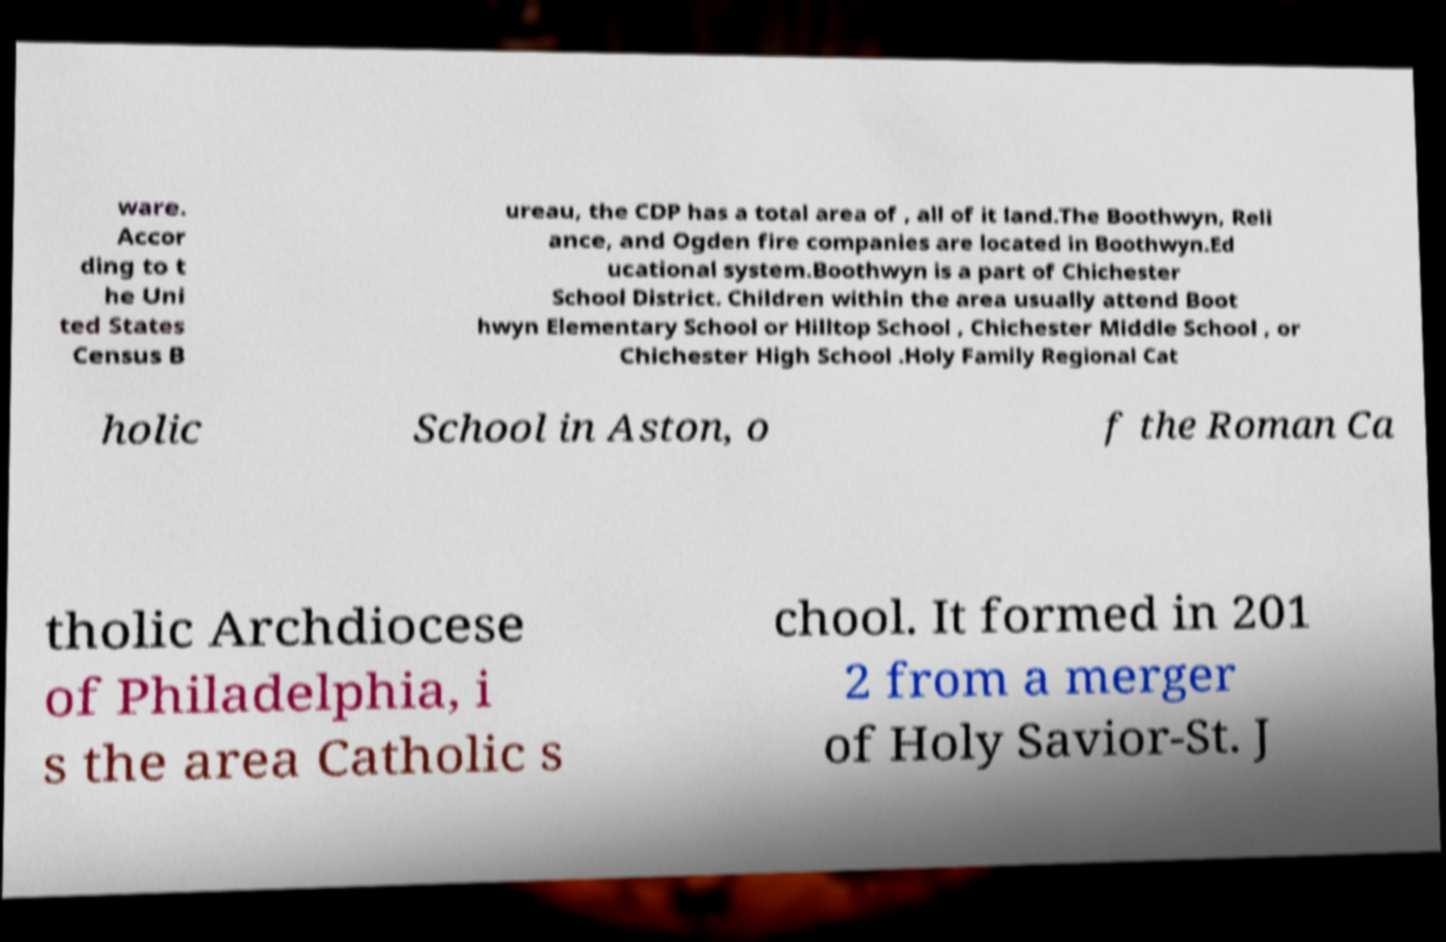Could you assist in decoding the text presented in this image and type it out clearly? ware. Accor ding to t he Uni ted States Census B ureau, the CDP has a total area of , all of it land.The Boothwyn, Reli ance, and Ogden fire companies are located in Boothwyn.Ed ucational system.Boothwyn is a part of Chichester School District. Children within the area usually attend Boot hwyn Elementary School or Hilltop School , Chichester Middle School , or Chichester High School .Holy Family Regional Cat holic School in Aston, o f the Roman Ca tholic Archdiocese of Philadelphia, i s the area Catholic s chool. It formed in 201 2 from a merger of Holy Savior-St. J 